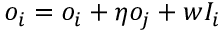<formula> <loc_0><loc_0><loc_500><loc_500>o _ { i } = o _ { i } + \eta o _ { j } + w I _ { i }</formula> 